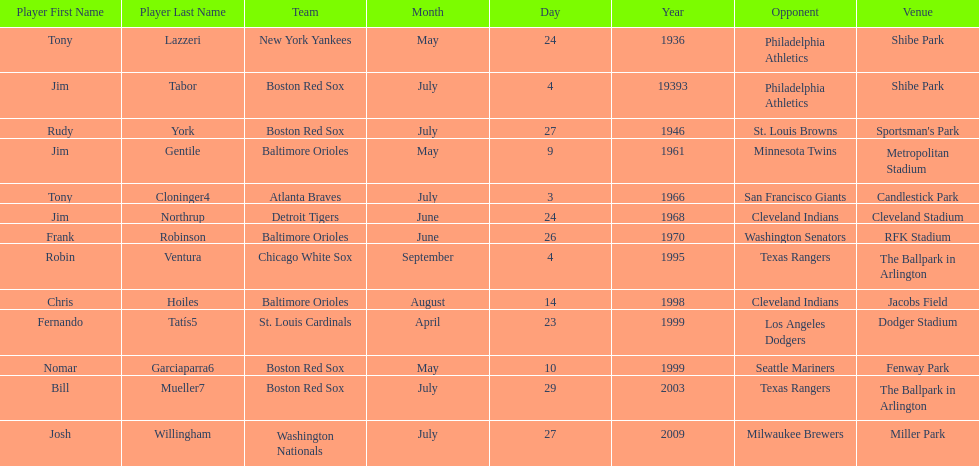Who is the first major league hitter to hit two grand slams in one game? Tony Lazzeri. 